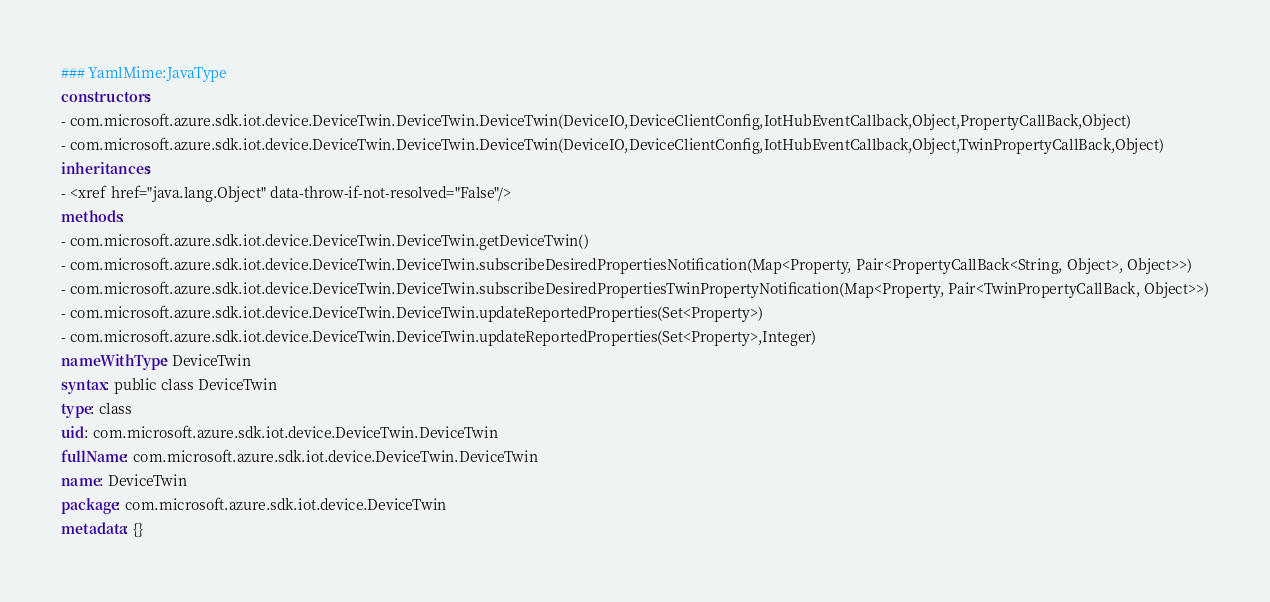Convert code to text. <code><loc_0><loc_0><loc_500><loc_500><_YAML_>### YamlMime:JavaType
constructors:
- com.microsoft.azure.sdk.iot.device.DeviceTwin.DeviceTwin.DeviceTwin(DeviceIO,DeviceClientConfig,IotHubEventCallback,Object,PropertyCallBack,Object)
- com.microsoft.azure.sdk.iot.device.DeviceTwin.DeviceTwin.DeviceTwin(DeviceIO,DeviceClientConfig,IotHubEventCallback,Object,TwinPropertyCallBack,Object)
inheritances:
- <xref href="java.lang.Object" data-throw-if-not-resolved="False"/>
methods:
- com.microsoft.azure.sdk.iot.device.DeviceTwin.DeviceTwin.getDeviceTwin()
- com.microsoft.azure.sdk.iot.device.DeviceTwin.DeviceTwin.subscribeDesiredPropertiesNotification(Map<Property, Pair<PropertyCallBack<String, Object>, Object>>)
- com.microsoft.azure.sdk.iot.device.DeviceTwin.DeviceTwin.subscribeDesiredPropertiesTwinPropertyNotification(Map<Property, Pair<TwinPropertyCallBack, Object>>)
- com.microsoft.azure.sdk.iot.device.DeviceTwin.DeviceTwin.updateReportedProperties(Set<Property>)
- com.microsoft.azure.sdk.iot.device.DeviceTwin.DeviceTwin.updateReportedProperties(Set<Property>,Integer)
nameWithType: DeviceTwin
syntax: public class DeviceTwin
type: class
uid: com.microsoft.azure.sdk.iot.device.DeviceTwin.DeviceTwin
fullName: com.microsoft.azure.sdk.iot.device.DeviceTwin.DeviceTwin
name: DeviceTwin
package: com.microsoft.azure.sdk.iot.device.DeviceTwin
metadata: {}
</code> 